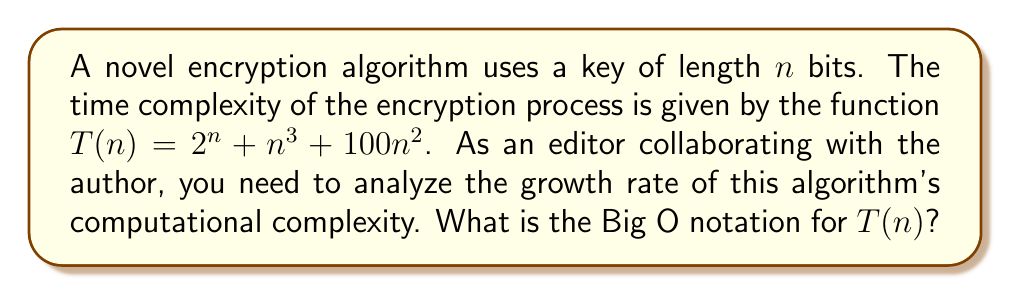Show me your answer to this math problem. To determine the Big O notation for $T(n) = 2^n + n^3 + 100n^2$, we need to identify the dominant term as $n$ approaches infinity. Let's analyze each term:

1. $2^n$: This is an exponential function.
2. $n^3$: This is a cubic polynomial function.
3. $100n^2$: This is a quadratic polynomial function.

As $n$ increases, the exponential function $2^n$ grows much faster than any polynomial function. Therefore:

$$\lim_{n \to \infty} \frac{2^n}{n^3} = \infty$$
$$\lim_{n \to \infty} \frac{2^n}{100n^2} = \infty$$

This means that $2^n$ dominates both $n^3$ and $100n^2$ for large values of $n$.

In Big O notation, we can disregard lower-order terms and constant factors. Thus, we can simplify $T(n)$ to:

$$T(n) = O(2^n)$$

This indicates that the computational complexity of the encryption algorithm grows exponentially with the key length, which is crucial information for accurately depicting the algorithm's performance in the novel.
Answer: $O(2^n)$ 